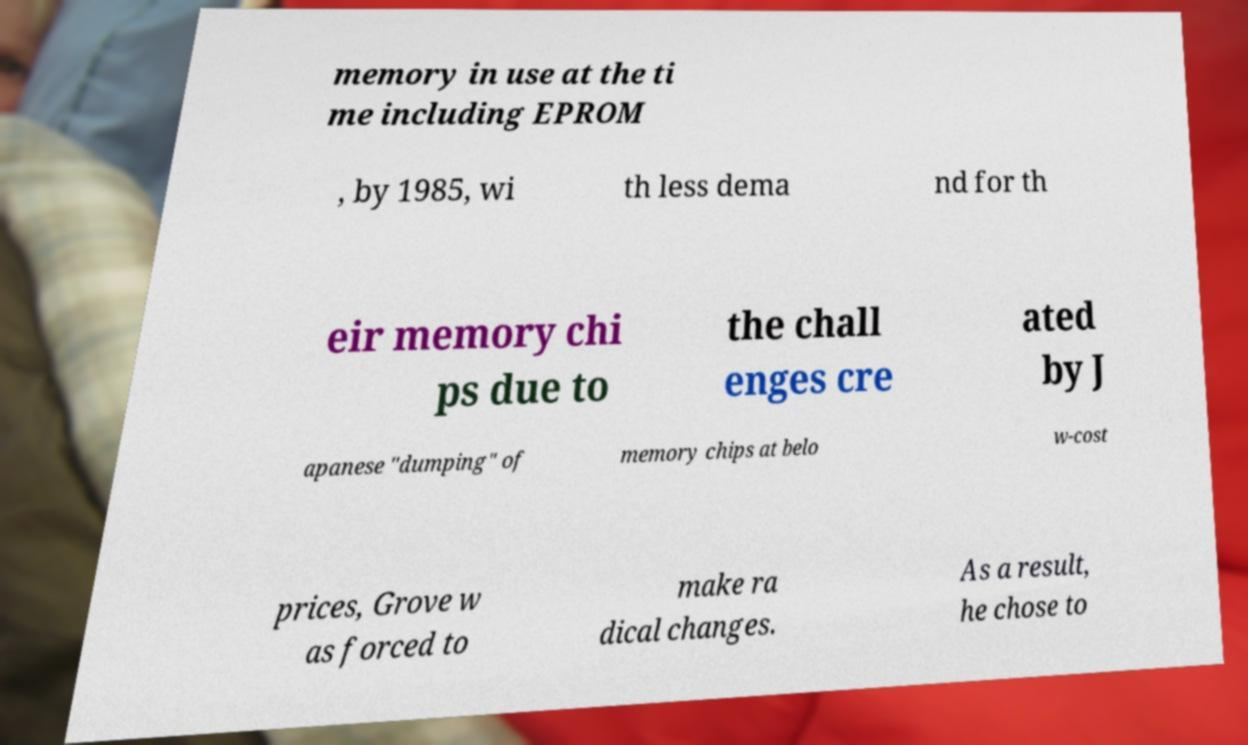What messages or text are displayed in this image? I need them in a readable, typed format. memory in use at the ti me including EPROM , by 1985, wi th less dema nd for th eir memory chi ps due to the chall enges cre ated by J apanese "dumping" of memory chips at belo w-cost prices, Grove w as forced to make ra dical changes. As a result, he chose to 